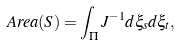<formula> <loc_0><loc_0><loc_500><loc_500>\ A r e a ( S ) = \int _ { \Pi } J ^ { - 1 } d \xi _ { s } d \xi _ { t } ,</formula> 